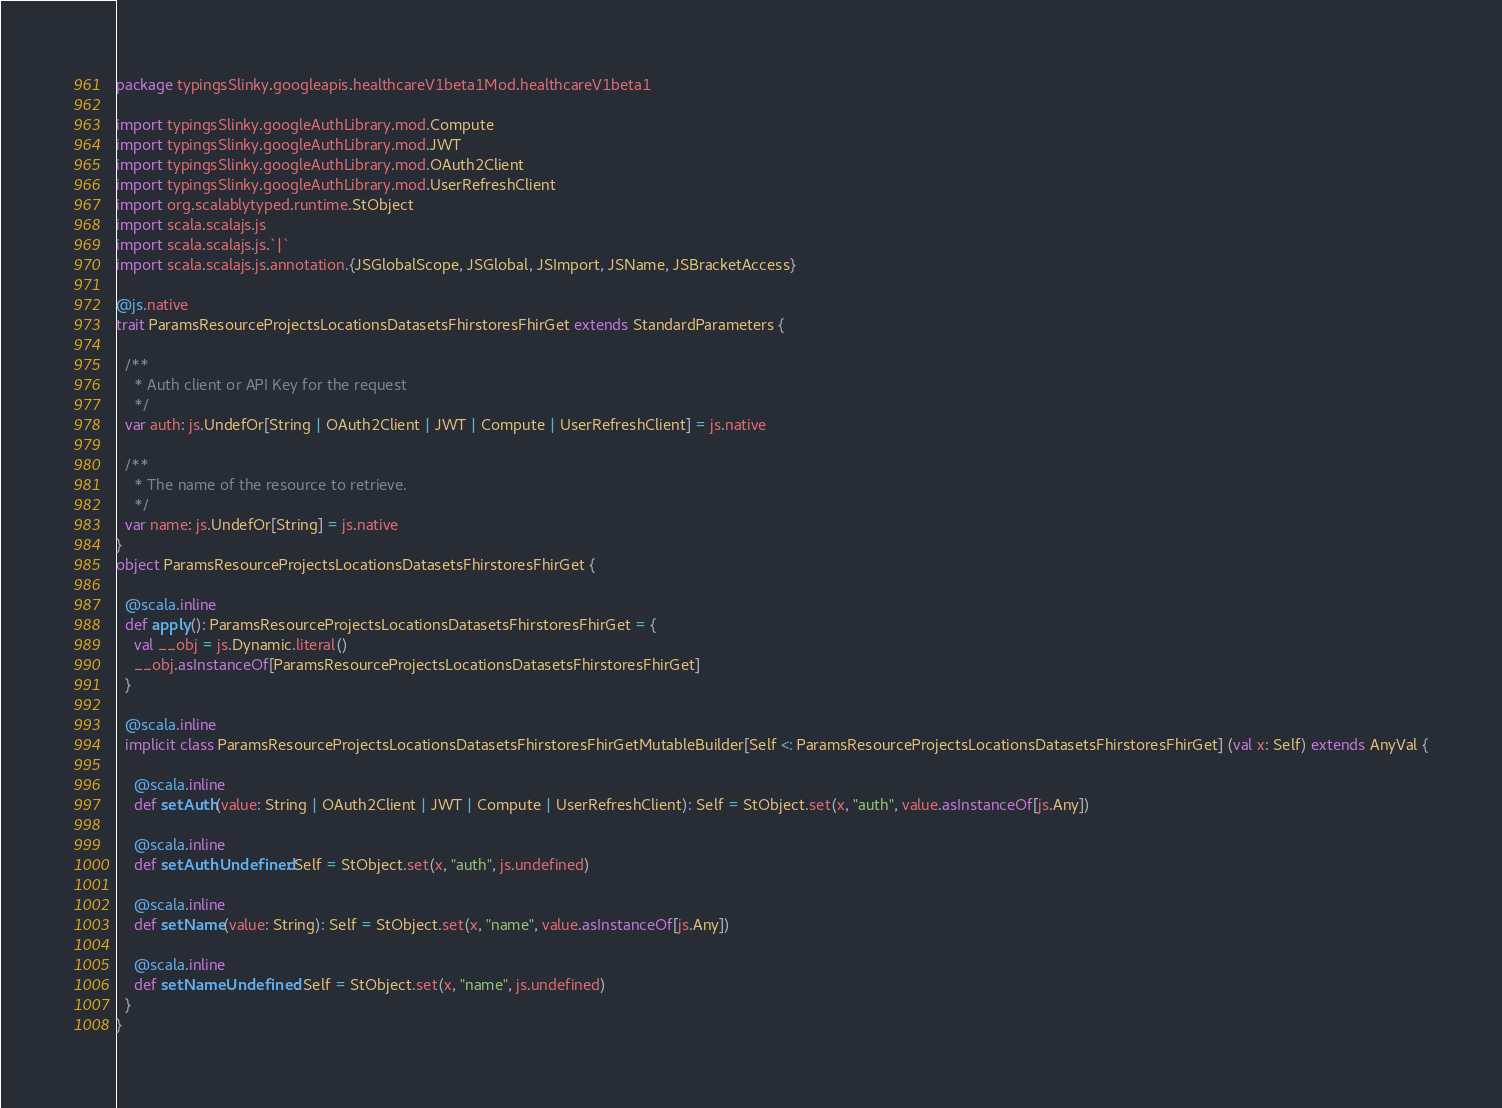Convert code to text. <code><loc_0><loc_0><loc_500><loc_500><_Scala_>package typingsSlinky.googleapis.healthcareV1beta1Mod.healthcareV1beta1

import typingsSlinky.googleAuthLibrary.mod.Compute
import typingsSlinky.googleAuthLibrary.mod.JWT
import typingsSlinky.googleAuthLibrary.mod.OAuth2Client
import typingsSlinky.googleAuthLibrary.mod.UserRefreshClient
import org.scalablytyped.runtime.StObject
import scala.scalajs.js
import scala.scalajs.js.`|`
import scala.scalajs.js.annotation.{JSGlobalScope, JSGlobal, JSImport, JSName, JSBracketAccess}

@js.native
trait ParamsResourceProjectsLocationsDatasetsFhirstoresFhirGet extends StandardParameters {
  
  /**
    * Auth client or API Key for the request
    */
  var auth: js.UndefOr[String | OAuth2Client | JWT | Compute | UserRefreshClient] = js.native
  
  /**
    * The name of the resource to retrieve.
    */
  var name: js.UndefOr[String] = js.native
}
object ParamsResourceProjectsLocationsDatasetsFhirstoresFhirGet {
  
  @scala.inline
  def apply(): ParamsResourceProjectsLocationsDatasetsFhirstoresFhirGet = {
    val __obj = js.Dynamic.literal()
    __obj.asInstanceOf[ParamsResourceProjectsLocationsDatasetsFhirstoresFhirGet]
  }
  
  @scala.inline
  implicit class ParamsResourceProjectsLocationsDatasetsFhirstoresFhirGetMutableBuilder[Self <: ParamsResourceProjectsLocationsDatasetsFhirstoresFhirGet] (val x: Self) extends AnyVal {
    
    @scala.inline
    def setAuth(value: String | OAuth2Client | JWT | Compute | UserRefreshClient): Self = StObject.set(x, "auth", value.asInstanceOf[js.Any])
    
    @scala.inline
    def setAuthUndefined: Self = StObject.set(x, "auth", js.undefined)
    
    @scala.inline
    def setName(value: String): Self = StObject.set(x, "name", value.asInstanceOf[js.Any])
    
    @scala.inline
    def setNameUndefined: Self = StObject.set(x, "name", js.undefined)
  }
}
</code> 